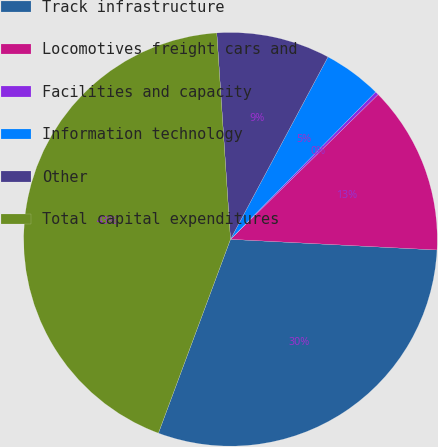Convert chart to OTSL. <chart><loc_0><loc_0><loc_500><loc_500><pie_chart><fcel>Track infrastructure<fcel>Locomotives freight cars and<fcel>Facilities and capacity<fcel>Information technology<fcel>Other<fcel>Total capital expenditures<nl><fcel>29.84%<fcel>13.17%<fcel>0.27%<fcel>4.57%<fcel>8.87%<fcel>43.28%<nl></chart> 